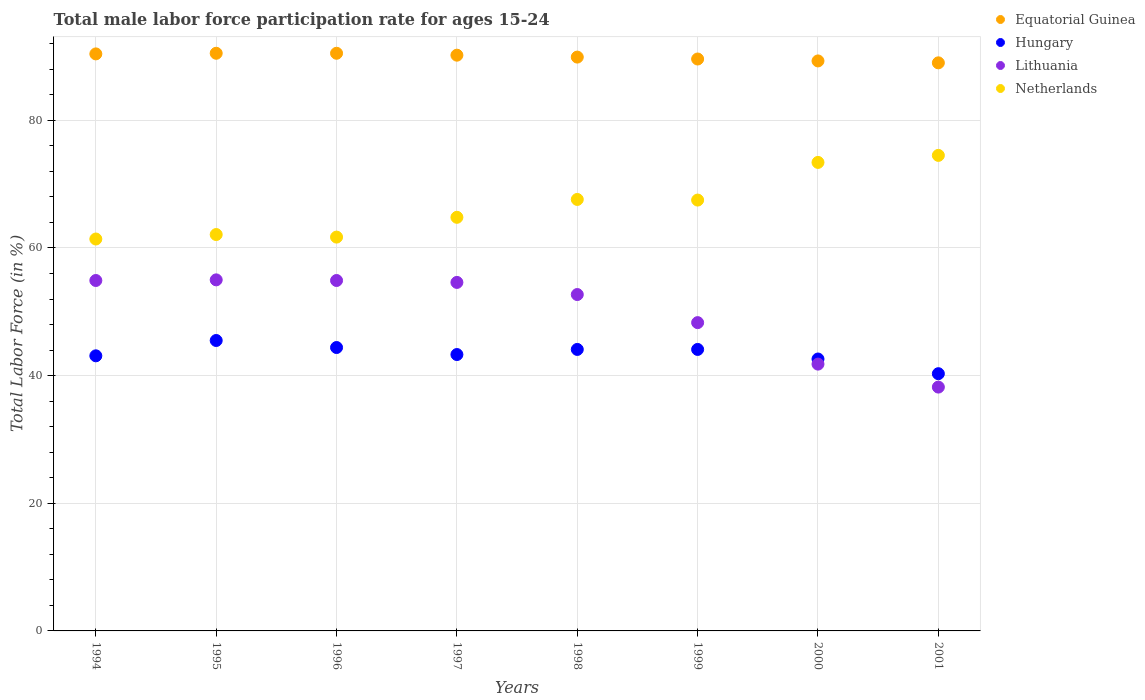How many different coloured dotlines are there?
Make the answer very short. 4. What is the male labor force participation rate in Netherlands in 1995?
Your answer should be compact. 62.1. Across all years, what is the maximum male labor force participation rate in Netherlands?
Offer a terse response. 74.5. Across all years, what is the minimum male labor force participation rate in Netherlands?
Keep it short and to the point. 61.4. In which year was the male labor force participation rate in Hungary minimum?
Keep it short and to the point. 2001. What is the total male labor force participation rate in Hungary in the graph?
Ensure brevity in your answer.  347.4. What is the difference between the male labor force participation rate in Netherlands in 1998 and that in 1999?
Give a very brief answer. 0.1. What is the difference between the male labor force participation rate in Lithuania in 1998 and the male labor force participation rate in Netherlands in 1997?
Ensure brevity in your answer.  -12.1. What is the average male labor force participation rate in Equatorial Guinea per year?
Keep it short and to the point. 89.93. In the year 2000, what is the difference between the male labor force participation rate in Lithuania and male labor force participation rate in Equatorial Guinea?
Make the answer very short. -47.5. What is the ratio of the male labor force participation rate in Lithuania in 1995 to that in 2001?
Offer a terse response. 1.44. What is the difference between the highest and the second highest male labor force participation rate in Lithuania?
Keep it short and to the point. 0.1. What is the difference between the highest and the lowest male labor force participation rate in Hungary?
Provide a succinct answer. 5.2. In how many years, is the male labor force participation rate in Hungary greater than the average male labor force participation rate in Hungary taken over all years?
Ensure brevity in your answer.  4. Is it the case that in every year, the sum of the male labor force participation rate in Equatorial Guinea and male labor force participation rate in Hungary  is greater than the sum of male labor force participation rate in Lithuania and male labor force participation rate in Netherlands?
Make the answer very short. No. How many dotlines are there?
Make the answer very short. 4. What is the difference between two consecutive major ticks on the Y-axis?
Provide a short and direct response. 20. Are the values on the major ticks of Y-axis written in scientific E-notation?
Your response must be concise. No. Does the graph contain any zero values?
Give a very brief answer. No. Does the graph contain grids?
Your response must be concise. Yes. Where does the legend appear in the graph?
Provide a short and direct response. Top right. How many legend labels are there?
Make the answer very short. 4. How are the legend labels stacked?
Offer a very short reply. Vertical. What is the title of the graph?
Give a very brief answer. Total male labor force participation rate for ages 15-24. What is the Total Labor Force (in %) of Equatorial Guinea in 1994?
Your answer should be very brief. 90.4. What is the Total Labor Force (in %) of Hungary in 1994?
Provide a succinct answer. 43.1. What is the Total Labor Force (in %) of Lithuania in 1994?
Offer a very short reply. 54.9. What is the Total Labor Force (in %) in Netherlands in 1994?
Ensure brevity in your answer.  61.4. What is the Total Labor Force (in %) in Equatorial Guinea in 1995?
Keep it short and to the point. 90.5. What is the Total Labor Force (in %) in Hungary in 1995?
Provide a short and direct response. 45.5. What is the Total Labor Force (in %) in Netherlands in 1995?
Provide a succinct answer. 62.1. What is the Total Labor Force (in %) of Equatorial Guinea in 1996?
Ensure brevity in your answer.  90.5. What is the Total Labor Force (in %) of Hungary in 1996?
Offer a very short reply. 44.4. What is the Total Labor Force (in %) in Lithuania in 1996?
Ensure brevity in your answer.  54.9. What is the Total Labor Force (in %) in Netherlands in 1996?
Give a very brief answer. 61.7. What is the Total Labor Force (in %) of Equatorial Guinea in 1997?
Provide a succinct answer. 90.2. What is the Total Labor Force (in %) of Hungary in 1997?
Offer a terse response. 43.3. What is the Total Labor Force (in %) in Lithuania in 1997?
Provide a succinct answer. 54.6. What is the Total Labor Force (in %) in Netherlands in 1997?
Keep it short and to the point. 64.8. What is the Total Labor Force (in %) in Equatorial Guinea in 1998?
Your answer should be very brief. 89.9. What is the Total Labor Force (in %) of Hungary in 1998?
Your response must be concise. 44.1. What is the Total Labor Force (in %) of Lithuania in 1998?
Your response must be concise. 52.7. What is the Total Labor Force (in %) in Netherlands in 1998?
Keep it short and to the point. 67.6. What is the Total Labor Force (in %) of Equatorial Guinea in 1999?
Ensure brevity in your answer.  89.6. What is the Total Labor Force (in %) of Hungary in 1999?
Keep it short and to the point. 44.1. What is the Total Labor Force (in %) of Lithuania in 1999?
Your response must be concise. 48.3. What is the Total Labor Force (in %) of Netherlands in 1999?
Offer a terse response. 67.5. What is the Total Labor Force (in %) of Equatorial Guinea in 2000?
Your answer should be very brief. 89.3. What is the Total Labor Force (in %) of Hungary in 2000?
Offer a terse response. 42.6. What is the Total Labor Force (in %) of Lithuania in 2000?
Your answer should be very brief. 41.8. What is the Total Labor Force (in %) of Netherlands in 2000?
Keep it short and to the point. 73.4. What is the Total Labor Force (in %) of Equatorial Guinea in 2001?
Your response must be concise. 89. What is the Total Labor Force (in %) in Hungary in 2001?
Offer a very short reply. 40.3. What is the Total Labor Force (in %) in Lithuania in 2001?
Provide a short and direct response. 38.2. What is the Total Labor Force (in %) in Netherlands in 2001?
Ensure brevity in your answer.  74.5. Across all years, what is the maximum Total Labor Force (in %) in Equatorial Guinea?
Your answer should be compact. 90.5. Across all years, what is the maximum Total Labor Force (in %) in Hungary?
Offer a very short reply. 45.5. Across all years, what is the maximum Total Labor Force (in %) in Netherlands?
Give a very brief answer. 74.5. Across all years, what is the minimum Total Labor Force (in %) of Equatorial Guinea?
Keep it short and to the point. 89. Across all years, what is the minimum Total Labor Force (in %) in Hungary?
Provide a succinct answer. 40.3. Across all years, what is the minimum Total Labor Force (in %) in Lithuania?
Provide a short and direct response. 38.2. Across all years, what is the minimum Total Labor Force (in %) in Netherlands?
Offer a terse response. 61.4. What is the total Total Labor Force (in %) of Equatorial Guinea in the graph?
Your response must be concise. 719.4. What is the total Total Labor Force (in %) of Hungary in the graph?
Your answer should be very brief. 347.4. What is the total Total Labor Force (in %) in Lithuania in the graph?
Your answer should be compact. 400.4. What is the total Total Labor Force (in %) in Netherlands in the graph?
Offer a very short reply. 533. What is the difference between the Total Labor Force (in %) of Lithuania in 1994 and that in 1995?
Offer a very short reply. -0.1. What is the difference between the Total Labor Force (in %) in Netherlands in 1994 and that in 1995?
Give a very brief answer. -0.7. What is the difference between the Total Labor Force (in %) in Netherlands in 1994 and that in 1996?
Offer a terse response. -0.3. What is the difference between the Total Labor Force (in %) of Equatorial Guinea in 1994 and that in 1997?
Give a very brief answer. 0.2. What is the difference between the Total Labor Force (in %) in Equatorial Guinea in 1994 and that in 1998?
Offer a very short reply. 0.5. What is the difference between the Total Labor Force (in %) in Lithuania in 1994 and that in 1998?
Make the answer very short. 2.2. What is the difference between the Total Labor Force (in %) in Equatorial Guinea in 1994 and that in 1999?
Offer a very short reply. 0.8. What is the difference between the Total Labor Force (in %) in Netherlands in 1994 and that in 1999?
Provide a short and direct response. -6.1. What is the difference between the Total Labor Force (in %) in Equatorial Guinea in 1994 and that in 2000?
Offer a terse response. 1.1. What is the difference between the Total Labor Force (in %) of Equatorial Guinea in 1994 and that in 2001?
Give a very brief answer. 1.4. What is the difference between the Total Labor Force (in %) in Netherlands in 1994 and that in 2001?
Give a very brief answer. -13.1. What is the difference between the Total Labor Force (in %) of Equatorial Guinea in 1995 and that in 1996?
Provide a succinct answer. 0. What is the difference between the Total Labor Force (in %) of Hungary in 1995 and that in 1996?
Your answer should be compact. 1.1. What is the difference between the Total Labor Force (in %) of Lithuania in 1995 and that in 1997?
Ensure brevity in your answer.  0.4. What is the difference between the Total Labor Force (in %) in Netherlands in 1995 and that in 1997?
Provide a short and direct response. -2.7. What is the difference between the Total Labor Force (in %) in Equatorial Guinea in 1995 and that in 1998?
Offer a terse response. 0.6. What is the difference between the Total Labor Force (in %) of Hungary in 1995 and that in 1998?
Provide a succinct answer. 1.4. What is the difference between the Total Labor Force (in %) of Netherlands in 1995 and that in 1998?
Ensure brevity in your answer.  -5.5. What is the difference between the Total Labor Force (in %) of Equatorial Guinea in 1995 and that in 1999?
Ensure brevity in your answer.  0.9. What is the difference between the Total Labor Force (in %) of Hungary in 1995 and that in 1999?
Offer a very short reply. 1.4. What is the difference between the Total Labor Force (in %) of Netherlands in 1995 and that in 1999?
Ensure brevity in your answer.  -5.4. What is the difference between the Total Labor Force (in %) in Equatorial Guinea in 1995 and that in 2000?
Ensure brevity in your answer.  1.2. What is the difference between the Total Labor Force (in %) in Hungary in 1995 and that in 2000?
Offer a terse response. 2.9. What is the difference between the Total Labor Force (in %) of Hungary in 1995 and that in 2001?
Offer a terse response. 5.2. What is the difference between the Total Labor Force (in %) of Netherlands in 1995 and that in 2001?
Your answer should be very brief. -12.4. What is the difference between the Total Labor Force (in %) in Hungary in 1996 and that in 1997?
Keep it short and to the point. 1.1. What is the difference between the Total Labor Force (in %) in Lithuania in 1996 and that in 1997?
Your answer should be compact. 0.3. What is the difference between the Total Labor Force (in %) in Equatorial Guinea in 1996 and that in 1998?
Provide a succinct answer. 0.6. What is the difference between the Total Labor Force (in %) in Lithuania in 1996 and that in 1998?
Your response must be concise. 2.2. What is the difference between the Total Labor Force (in %) of Equatorial Guinea in 1996 and that in 1999?
Your answer should be compact. 0.9. What is the difference between the Total Labor Force (in %) in Hungary in 1996 and that in 1999?
Provide a short and direct response. 0.3. What is the difference between the Total Labor Force (in %) in Equatorial Guinea in 1996 and that in 2000?
Give a very brief answer. 1.2. What is the difference between the Total Labor Force (in %) of Hungary in 1996 and that in 2000?
Your answer should be very brief. 1.8. What is the difference between the Total Labor Force (in %) of Lithuania in 1996 and that in 2000?
Your answer should be compact. 13.1. What is the difference between the Total Labor Force (in %) of Netherlands in 1996 and that in 2000?
Provide a succinct answer. -11.7. What is the difference between the Total Labor Force (in %) in Equatorial Guinea in 1996 and that in 2001?
Make the answer very short. 1.5. What is the difference between the Total Labor Force (in %) in Equatorial Guinea in 1997 and that in 1998?
Your answer should be compact. 0.3. What is the difference between the Total Labor Force (in %) of Equatorial Guinea in 1997 and that in 1999?
Your answer should be compact. 0.6. What is the difference between the Total Labor Force (in %) in Netherlands in 1997 and that in 1999?
Keep it short and to the point. -2.7. What is the difference between the Total Labor Force (in %) of Equatorial Guinea in 1997 and that in 2001?
Keep it short and to the point. 1.2. What is the difference between the Total Labor Force (in %) in Netherlands in 1997 and that in 2001?
Provide a succinct answer. -9.7. What is the difference between the Total Labor Force (in %) of Netherlands in 1998 and that in 2000?
Keep it short and to the point. -5.8. What is the difference between the Total Labor Force (in %) in Hungary in 1998 and that in 2001?
Give a very brief answer. 3.8. What is the difference between the Total Labor Force (in %) in Lithuania in 1998 and that in 2001?
Keep it short and to the point. 14.5. What is the difference between the Total Labor Force (in %) in Netherlands in 1998 and that in 2001?
Keep it short and to the point. -6.9. What is the difference between the Total Labor Force (in %) of Hungary in 1999 and that in 2000?
Give a very brief answer. 1.5. What is the difference between the Total Labor Force (in %) in Lithuania in 1999 and that in 2000?
Offer a terse response. 6.5. What is the difference between the Total Labor Force (in %) in Netherlands in 1999 and that in 2000?
Make the answer very short. -5.9. What is the difference between the Total Labor Force (in %) in Netherlands in 1999 and that in 2001?
Make the answer very short. -7. What is the difference between the Total Labor Force (in %) in Hungary in 2000 and that in 2001?
Make the answer very short. 2.3. What is the difference between the Total Labor Force (in %) in Lithuania in 2000 and that in 2001?
Ensure brevity in your answer.  3.6. What is the difference between the Total Labor Force (in %) in Equatorial Guinea in 1994 and the Total Labor Force (in %) in Hungary in 1995?
Your answer should be very brief. 44.9. What is the difference between the Total Labor Force (in %) of Equatorial Guinea in 1994 and the Total Labor Force (in %) of Lithuania in 1995?
Make the answer very short. 35.4. What is the difference between the Total Labor Force (in %) of Equatorial Guinea in 1994 and the Total Labor Force (in %) of Netherlands in 1995?
Your answer should be very brief. 28.3. What is the difference between the Total Labor Force (in %) of Equatorial Guinea in 1994 and the Total Labor Force (in %) of Lithuania in 1996?
Offer a terse response. 35.5. What is the difference between the Total Labor Force (in %) of Equatorial Guinea in 1994 and the Total Labor Force (in %) of Netherlands in 1996?
Provide a succinct answer. 28.7. What is the difference between the Total Labor Force (in %) in Hungary in 1994 and the Total Labor Force (in %) in Lithuania in 1996?
Give a very brief answer. -11.8. What is the difference between the Total Labor Force (in %) of Hungary in 1994 and the Total Labor Force (in %) of Netherlands in 1996?
Your answer should be compact. -18.6. What is the difference between the Total Labor Force (in %) of Lithuania in 1994 and the Total Labor Force (in %) of Netherlands in 1996?
Ensure brevity in your answer.  -6.8. What is the difference between the Total Labor Force (in %) of Equatorial Guinea in 1994 and the Total Labor Force (in %) of Hungary in 1997?
Your answer should be compact. 47.1. What is the difference between the Total Labor Force (in %) of Equatorial Guinea in 1994 and the Total Labor Force (in %) of Lithuania in 1997?
Provide a succinct answer. 35.8. What is the difference between the Total Labor Force (in %) of Equatorial Guinea in 1994 and the Total Labor Force (in %) of Netherlands in 1997?
Offer a very short reply. 25.6. What is the difference between the Total Labor Force (in %) in Hungary in 1994 and the Total Labor Force (in %) in Netherlands in 1997?
Keep it short and to the point. -21.7. What is the difference between the Total Labor Force (in %) in Equatorial Guinea in 1994 and the Total Labor Force (in %) in Hungary in 1998?
Ensure brevity in your answer.  46.3. What is the difference between the Total Labor Force (in %) in Equatorial Guinea in 1994 and the Total Labor Force (in %) in Lithuania in 1998?
Offer a very short reply. 37.7. What is the difference between the Total Labor Force (in %) in Equatorial Guinea in 1994 and the Total Labor Force (in %) in Netherlands in 1998?
Your answer should be compact. 22.8. What is the difference between the Total Labor Force (in %) in Hungary in 1994 and the Total Labor Force (in %) in Netherlands in 1998?
Your response must be concise. -24.5. What is the difference between the Total Labor Force (in %) in Equatorial Guinea in 1994 and the Total Labor Force (in %) in Hungary in 1999?
Your answer should be compact. 46.3. What is the difference between the Total Labor Force (in %) in Equatorial Guinea in 1994 and the Total Labor Force (in %) in Lithuania in 1999?
Provide a succinct answer. 42.1. What is the difference between the Total Labor Force (in %) in Equatorial Guinea in 1994 and the Total Labor Force (in %) in Netherlands in 1999?
Your answer should be compact. 22.9. What is the difference between the Total Labor Force (in %) of Hungary in 1994 and the Total Labor Force (in %) of Lithuania in 1999?
Make the answer very short. -5.2. What is the difference between the Total Labor Force (in %) in Hungary in 1994 and the Total Labor Force (in %) in Netherlands in 1999?
Your answer should be very brief. -24.4. What is the difference between the Total Labor Force (in %) in Lithuania in 1994 and the Total Labor Force (in %) in Netherlands in 1999?
Your answer should be compact. -12.6. What is the difference between the Total Labor Force (in %) of Equatorial Guinea in 1994 and the Total Labor Force (in %) of Hungary in 2000?
Your response must be concise. 47.8. What is the difference between the Total Labor Force (in %) of Equatorial Guinea in 1994 and the Total Labor Force (in %) of Lithuania in 2000?
Your answer should be very brief. 48.6. What is the difference between the Total Labor Force (in %) of Equatorial Guinea in 1994 and the Total Labor Force (in %) of Netherlands in 2000?
Make the answer very short. 17. What is the difference between the Total Labor Force (in %) of Hungary in 1994 and the Total Labor Force (in %) of Lithuania in 2000?
Offer a terse response. 1.3. What is the difference between the Total Labor Force (in %) in Hungary in 1994 and the Total Labor Force (in %) in Netherlands in 2000?
Provide a succinct answer. -30.3. What is the difference between the Total Labor Force (in %) in Lithuania in 1994 and the Total Labor Force (in %) in Netherlands in 2000?
Your answer should be compact. -18.5. What is the difference between the Total Labor Force (in %) in Equatorial Guinea in 1994 and the Total Labor Force (in %) in Hungary in 2001?
Your answer should be very brief. 50.1. What is the difference between the Total Labor Force (in %) of Equatorial Guinea in 1994 and the Total Labor Force (in %) of Lithuania in 2001?
Your answer should be very brief. 52.2. What is the difference between the Total Labor Force (in %) of Equatorial Guinea in 1994 and the Total Labor Force (in %) of Netherlands in 2001?
Your answer should be very brief. 15.9. What is the difference between the Total Labor Force (in %) of Hungary in 1994 and the Total Labor Force (in %) of Lithuania in 2001?
Offer a terse response. 4.9. What is the difference between the Total Labor Force (in %) in Hungary in 1994 and the Total Labor Force (in %) in Netherlands in 2001?
Keep it short and to the point. -31.4. What is the difference between the Total Labor Force (in %) of Lithuania in 1994 and the Total Labor Force (in %) of Netherlands in 2001?
Your answer should be compact. -19.6. What is the difference between the Total Labor Force (in %) in Equatorial Guinea in 1995 and the Total Labor Force (in %) in Hungary in 1996?
Keep it short and to the point. 46.1. What is the difference between the Total Labor Force (in %) in Equatorial Guinea in 1995 and the Total Labor Force (in %) in Lithuania in 1996?
Your answer should be very brief. 35.6. What is the difference between the Total Labor Force (in %) in Equatorial Guinea in 1995 and the Total Labor Force (in %) in Netherlands in 1996?
Keep it short and to the point. 28.8. What is the difference between the Total Labor Force (in %) of Hungary in 1995 and the Total Labor Force (in %) of Lithuania in 1996?
Your answer should be compact. -9.4. What is the difference between the Total Labor Force (in %) in Hungary in 1995 and the Total Labor Force (in %) in Netherlands in 1996?
Make the answer very short. -16.2. What is the difference between the Total Labor Force (in %) in Lithuania in 1995 and the Total Labor Force (in %) in Netherlands in 1996?
Your response must be concise. -6.7. What is the difference between the Total Labor Force (in %) in Equatorial Guinea in 1995 and the Total Labor Force (in %) in Hungary in 1997?
Give a very brief answer. 47.2. What is the difference between the Total Labor Force (in %) of Equatorial Guinea in 1995 and the Total Labor Force (in %) of Lithuania in 1997?
Your response must be concise. 35.9. What is the difference between the Total Labor Force (in %) of Equatorial Guinea in 1995 and the Total Labor Force (in %) of Netherlands in 1997?
Give a very brief answer. 25.7. What is the difference between the Total Labor Force (in %) in Hungary in 1995 and the Total Labor Force (in %) in Netherlands in 1997?
Provide a succinct answer. -19.3. What is the difference between the Total Labor Force (in %) of Lithuania in 1995 and the Total Labor Force (in %) of Netherlands in 1997?
Give a very brief answer. -9.8. What is the difference between the Total Labor Force (in %) of Equatorial Guinea in 1995 and the Total Labor Force (in %) of Hungary in 1998?
Give a very brief answer. 46.4. What is the difference between the Total Labor Force (in %) in Equatorial Guinea in 1995 and the Total Labor Force (in %) in Lithuania in 1998?
Your answer should be very brief. 37.8. What is the difference between the Total Labor Force (in %) in Equatorial Guinea in 1995 and the Total Labor Force (in %) in Netherlands in 1998?
Make the answer very short. 22.9. What is the difference between the Total Labor Force (in %) of Hungary in 1995 and the Total Labor Force (in %) of Lithuania in 1998?
Keep it short and to the point. -7.2. What is the difference between the Total Labor Force (in %) of Hungary in 1995 and the Total Labor Force (in %) of Netherlands in 1998?
Make the answer very short. -22.1. What is the difference between the Total Labor Force (in %) in Equatorial Guinea in 1995 and the Total Labor Force (in %) in Hungary in 1999?
Your answer should be compact. 46.4. What is the difference between the Total Labor Force (in %) of Equatorial Guinea in 1995 and the Total Labor Force (in %) of Lithuania in 1999?
Offer a terse response. 42.2. What is the difference between the Total Labor Force (in %) of Equatorial Guinea in 1995 and the Total Labor Force (in %) of Hungary in 2000?
Your answer should be very brief. 47.9. What is the difference between the Total Labor Force (in %) of Equatorial Guinea in 1995 and the Total Labor Force (in %) of Lithuania in 2000?
Give a very brief answer. 48.7. What is the difference between the Total Labor Force (in %) in Hungary in 1995 and the Total Labor Force (in %) in Netherlands in 2000?
Your answer should be compact. -27.9. What is the difference between the Total Labor Force (in %) in Lithuania in 1995 and the Total Labor Force (in %) in Netherlands in 2000?
Your answer should be compact. -18.4. What is the difference between the Total Labor Force (in %) of Equatorial Guinea in 1995 and the Total Labor Force (in %) of Hungary in 2001?
Your answer should be compact. 50.2. What is the difference between the Total Labor Force (in %) of Equatorial Guinea in 1995 and the Total Labor Force (in %) of Lithuania in 2001?
Offer a terse response. 52.3. What is the difference between the Total Labor Force (in %) of Equatorial Guinea in 1995 and the Total Labor Force (in %) of Netherlands in 2001?
Your response must be concise. 16. What is the difference between the Total Labor Force (in %) in Hungary in 1995 and the Total Labor Force (in %) in Netherlands in 2001?
Provide a succinct answer. -29. What is the difference between the Total Labor Force (in %) of Lithuania in 1995 and the Total Labor Force (in %) of Netherlands in 2001?
Offer a terse response. -19.5. What is the difference between the Total Labor Force (in %) in Equatorial Guinea in 1996 and the Total Labor Force (in %) in Hungary in 1997?
Your answer should be compact. 47.2. What is the difference between the Total Labor Force (in %) of Equatorial Guinea in 1996 and the Total Labor Force (in %) of Lithuania in 1997?
Keep it short and to the point. 35.9. What is the difference between the Total Labor Force (in %) in Equatorial Guinea in 1996 and the Total Labor Force (in %) in Netherlands in 1997?
Provide a succinct answer. 25.7. What is the difference between the Total Labor Force (in %) of Hungary in 1996 and the Total Labor Force (in %) of Lithuania in 1997?
Offer a terse response. -10.2. What is the difference between the Total Labor Force (in %) of Hungary in 1996 and the Total Labor Force (in %) of Netherlands in 1997?
Offer a very short reply. -20.4. What is the difference between the Total Labor Force (in %) of Lithuania in 1996 and the Total Labor Force (in %) of Netherlands in 1997?
Give a very brief answer. -9.9. What is the difference between the Total Labor Force (in %) of Equatorial Guinea in 1996 and the Total Labor Force (in %) of Hungary in 1998?
Keep it short and to the point. 46.4. What is the difference between the Total Labor Force (in %) in Equatorial Guinea in 1996 and the Total Labor Force (in %) in Lithuania in 1998?
Make the answer very short. 37.8. What is the difference between the Total Labor Force (in %) of Equatorial Guinea in 1996 and the Total Labor Force (in %) of Netherlands in 1998?
Give a very brief answer. 22.9. What is the difference between the Total Labor Force (in %) in Hungary in 1996 and the Total Labor Force (in %) in Netherlands in 1998?
Offer a very short reply. -23.2. What is the difference between the Total Labor Force (in %) of Equatorial Guinea in 1996 and the Total Labor Force (in %) of Hungary in 1999?
Your answer should be compact. 46.4. What is the difference between the Total Labor Force (in %) of Equatorial Guinea in 1996 and the Total Labor Force (in %) of Lithuania in 1999?
Provide a short and direct response. 42.2. What is the difference between the Total Labor Force (in %) of Hungary in 1996 and the Total Labor Force (in %) of Lithuania in 1999?
Provide a succinct answer. -3.9. What is the difference between the Total Labor Force (in %) of Hungary in 1996 and the Total Labor Force (in %) of Netherlands in 1999?
Offer a terse response. -23.1. What is the difference between the Total Labor Force (in %) in Equatorial Guinea in 1996 and the Total Labor Force (in %) in Hungary in 2000?
Give a very brief answer. 47.9. What is the difference between the Total Labor Force (in %) of Equatorial Guinea in 1996 and the Total Labor Force (in %) of Lithuania in 2000?
Make the answer very short. 48.7. What is the difference between the Total Labor Force (in %) in Hungary in 1996 and the Total Labor Force (in %) in Lithuania in 2000?
Make the answer very short. 2.6. What is the difference between the Total Labor Force (in %) of Hungary in 1996 and the Total Labor Force (in %) of Netherlands in 2000?
Your answer should be compact. -29. What is the difference between the Total Labor Force (in %) in Lithuania in 1996 and the Total Labor Force (in %) in Netherlands in 2000?
Keep it short and to the point. -18.5. What is the difference between the Total Labor Force (in %) in Equatorial Guinea in 1996 and the Total Labor Force (in %) in Hungary in 2001?
Offer a very short reply. 50.2. What is the difference between the Total Labor Force (in %) of Equatorial Guinea in 1996 and the Total Labor Force (in %) of Lithuania in 2001?
Ensure brevity in your answer.  52.3. What is the difference between the Total Labor Force (in %) in Hungary in 1996 and the Total Labor Force (in %) in Lithuania in 2001?
Provide a short and direct response. 6.2. What is the difference between the Total Labor Force (in %) of Hungary in 1996 and the Total Labor Force (in %) of Netherlands in 2001?
Make the answer very short. -30.1. What is the difference between the Total Labor Force (in %) in Lithuania in 1996 and the Total Labor Force (in %) in Netherlands in 2001?
Give a very brief answer. -19.6. What is the difference between the Total Labor Force (in %) in Equatorial Guinea in 1997 and the Total Labor Force (in %) in Hungary in 1998?
Offer a terse response. 46.1. What is the difference between the Total Labor Force (in %) in Equatorial Guinea in 1997 and the Total Labor Force (in %) in Lithuania in 1998?
Offer a very short reply. 37.5. What is the difference between the Total Labor Force (in %) of Equatorial Guinea in 1997 and the Total Labor Force (in %) of Netherlands in 1998?
Your answer should be very brief. 22.6. What is the difference between the Total Labor Force (in %) of Hungary in 1997 and the Total Labor Force (in %) of Lithuania in 1998?
Make the answer very short. -9.4. What is the difference between the Total Labor Force (in %) in Hungary in 1997 and the Total Labor Force (in %) in Netherlands in 1998?
Your answer should be compact. -24.3. What is the difference between the Total Labor Force (in %) of Lithuania in 1997 and the Total Labor Force (in %) of Netherlands in 1998?
Give a very brief answer. -13. What is the difference between the Total Labor Force (in %) in Equatorial Guinea in 1997 and the Total Labor Force (in %) in Hungary in 1999?
Your answer should be compact. 46.1. What is the difference between the Total Labor Force (in %) in Equatorial Guinea in 1997 and the Total Labor Force (in %) in Lithuania in 1999?
Ensure brevity in your answer.  41.9. What is the difference between the Total Labor Force (in %) of Equatorial Guinea in 1997 and the Total Labor Force (in %) of Netherlands in 1999?
Provide a short and direct response. 22.7. What is the difference between the Total Labor Force (in %) in Hungary in 1997 and the Total Labor Force (in %) in Lithuania in 1999?
Provide a succinct answer. -5. What is the difference between the Total Labor Force (in %) of Hungary in 1997 and the Total Labor Force (in %) of Netherlands in 1999?
Your response must be concise. -24.2. What is the difference between the Total Labor Force (in %) in Lithuania in 1997 and the Total Labor Force (in %) in Netherlands in 1999?
Make the answer very short. -12.9. What is the difference between the Total Labor Force (in %) of Equatorial Guinea in 1997 and the Total Labor Force (in %) of Hungary in 2000?
Offer a very short reply. 47.6. What is the difference between the Total Labor Force (in %) of Equatorial Guinea in 1997 and the Total Labor Force (in %) of Lithuania in 2000?
Your answer should be very brief. 48.4. What is the difference between the Total Labor Force (in %) in Hungary in 1997 and the Total Labor Force (in %) in Lithuania in 2000?
Make the answer very short. 1.5. What is the difference between the Total Labor Force (in %) in Hungary in 1997 and the Total Labor Force (in %) in Netherlands in 2000?
Make the answer very short. -30.1. What is the difference between the Total Labor Force (in %) in Lithuania in 1997 and the Total Labor Force (in %) in Netherlands in 2000?
Ensure brevity in your answer.  -18.8. What is the difference between the Total Labor Force (in %) in Equatorial Guinea in 1997 and the Total Labor Force (in %) in Hungary in 2001?
Provide a succinct answer. 49.9. What is the difference between the Total Labor Force (in %) of Hungary in 1997 and the Total Labor Force (in %) of Lithuania in 2001?
Keep it short and to the point. 5.1. What is the difference between the Total Labor Force (in %) of Hungary in 1997 and the Total Labor Force (in %) of Netherlands in 2001?
Provide a succinct answer. -31.2. What is the difference between the Total Labor Force (in %) in Lithuania in 1997 and the Total Labor Force (in %) in Netherlands in 2001?
Make the answer very short. -19.9. What is the difference between the Total Labor Force (in %) of Equatorial Guinea in 1998 and the Total Labor Force (in %) of Hungary in 1999?
Keep it short and to the point. 45.8. What is the difference between the Total Labor Force (in %) of Equatorial Guinea in 1998 and the Total Labor Force (in %) of Lithuania in 1999?
Give a very brief answer. 41.6. What is the difference between the Total Labor Force (in %) in Equatorial Guinea in 1998 and the Total Labor Force (in %) in Netherlands in 1999?
Provide a short and direct response. 22.4. What is the difference between the Total Labor Force (in %) of Hungary in 1998 and the Total Labor Force (in %) of Lithuania in 1999?
Offer a terse response. -4.2. What is the difference between the Total Labor Force (in %) in Hungary in 1998 and the Total Labor Force (in %) in Netherlands in 1999?
Your response must be concise. -23.4. What is the difference between the Total Labor Force (in %) of Lithuania in 1998 and the Total Labor Force (in %) of Netherlands in 1999?
Offer a terse response. -14.8. What is the difference between the Total Labor Force (in %) of Equatorial Guinea in 1998 and the Total Labor Force (in %) of Hungary in 2000?
Ensure brevity in your answer.  47.3. What is the difference between the Total Labor Force (in %) in Equatorial Guinea in 1998 and the Total Labor Force (in %) in Lithuania in 2000?
Give a very brief answer. 48.1. What is the difference between the Total Labor Force (in %) in Hungary in 1998 and the Total Labor Force (in %) in Lithuania in 2000?
Your response must be concise. 2.3. What is the difference between the Total Labor Force (in %) of Hungary in 1998 and the Total Labor Force (in %) of Netherlands in 2000?
Offer a terse response. -29.3. What is the difference between the Total Labor Force (in %) of Lithuania in 1998 and the Total Labor Force (in %) of Netherlands in 2000?
Your response must be concise. -20.7. What is the difference between the Total Labor Force (in %) of Equatorial Guinea in 1998 and the Total Labor Force (in %) of Hungary in 2001?
Keep it short and to the point. 49.6. What is the difference between the Total Labor Force (in %) of Equatorial Guinea in 1998 and the Total Labor Force (in %) of Lithuania in 2001?
Provide a succinct answer. 51.7. What is the difference between the Total Labor Force (in %) in Equatorial Guinea in 1998 and the Total Labor Force (in %) in Netherlands in 2001?
Provide a succinct answer. 15.4. What is the difference between the Total Labor Force (in %) in Hungary in 1998 and the Total Labor Force (in %) in Lithuania in 2001?
Offer a very short reply. 5.9. What is the difference between the Total Labor Force (in %) in Hungary in 1998 and the Total Labor Force (in %) in Netherlands in 2001?
Your response must be concise. -30.4. What is the difference between the Total Labor Force (in %) in Lithuania in 1998 and the Total Labor Force (in %) in Netherlands in 2001?
Keep it short and to the point. -21.8. What is the difference between the Total Labor Force (in %) in Equatorial Guinea in 1999 and the Total Labor Force (in %) in Hungary in 2000?
Offer a very short reply. 47. What is the difference between the Total Labor Force (in %) in Equatorial Guinea in 1999 and the Total Labor Force (in %) in Lithuania in 2000?
Offer a very short reply. 47.8. What is the difference between the Total Labor Force (in %) in Equatorial Guinea in 1999 and the Total Labor Force (in %) in Netherlands in 2000?
Make the answer very short. 16.2. What is the difference between the Total Labor Force (in %) in Hungary in 1999 and the Total Labor Force (in %) in Lithuania in 2000?
Your answer should be very brief. 2.3. What is the difference between the Total Labor Force (in %) of Hungary in 1999 and the Total Labor Force (in %) of Netherlands in 2000?
Ensure brevity in your answer.  -29.3. What is the difference between the Total Labor Force (in %) of Lithuania in 1999 and the Total Labor Force (in %) of Netherlands in 2000?
Provide a succinct answer. -25.1. What is the difference between the Total Labor Force (in %) in Equatorial Guinea in 1999 and the Total Labor Force (in %) in Hungary in 2001?
Ensure brevity in your answer.  49.3. What is the difference between the Total Labor Force (in %) of Equatorial Guinea in 1999 and the Total Labor Force (in %) of Lithuania in 2001?
Your answer should be very brief. 51.4. What is the difference between the Total Labor Force (in %) in Hungary in 1999 and the Total Labor Force (in %) in Lithuania in 2001?
Provide a succinct answer. 5.9. What is the difference between the Total Labor Force (in %) of Hungary in 1999 and the Total Labor Force (in %) of Netherlands in 2001?
Keep it short and to the point. -30.4. What is the difference between the Total Labor Force (in %) in Lithuania in 1999 and the Total Labor Force (in %) in Netherlands in 2001?
Keep it short and to the point. -26.2. What is the difference between the Total Labor Force (in %) of Equatorial Guinea in 2000 and the Total Labor Force (in %) of Lithuania in 2001?
Offer a very short reply. 51.1. What is the difference between the Total Labor Force (in %) in Hungary in 2000 and the Total Labor Force (in %) in Lithuania in 2001?
Your answer should be very brief. 4.4. What is the difference between the Total Labor Force (in %) of Hungary in 2000 and the Total Labor Force (in %) of Netherlands in 2001?
Provide a short and direct response. -31.9. What is the difference between the Total Labor Force (in %) in Lithuania in 2000 and the Total Labor Force (in %) in Netherlands in 2001?
Make the answer very short. -32.7. What is the average Total Labor Force (in %) of Equatorial Guinea per year?
Offer a very short reply. 89.92. What is the average Total Labor Force (in %) in Hungary per year?
Provide a short and direct response. 43.42. What is the average Total Labor Force (in %) of Lithuania per year?
Keep it short and to the point. 50.05. What is the average Total Labor Force (in %) in Netherlands per year?
Provide a short and direct response. 66.62. In the year 1994, what is the difference between the Total Labor Force (in %) in Equatorial Guinea and Total Labor Force (in %) in Hungary?
Provide a short and direct response. 47.3. In the year 1994, what is the difference between the Total Labor Force (in %) in Equatorial Guinea and Total Labor Force (in %) in Lithuania?
Ensure brevity in your answer.  35.5. In the year 1994, what is the difference between the Total Labor Force (in %) of Equatorial Guinea and Total Labor Force (in %) of Netherlands?
Offer a terse response. 29. In the year 1994, what is the difference between the Total Labor Force (in %) of Hungary and Total Labor Force (in %) of Lithuania?
Offer a very short reply. -11.8. In the year 1994, what is the difference between the Total Labor Force (in %) in Hungary and Total Labor Force (in %) in Netherlands?
Offer a very short reply. -18.3. In the year 1994, what is the difference between the Total Labor Force (in %) in Lithuania and Total Labor Force (in %) in Netherlands?
Make the answer very short. -6.5. In the year 1995, what is the difference between the Total Labor Force (in %) of Equatorial Guinea and Total Labor Force (in %) of Hungary?
Offer a very short reply. 45. In the year 1995, what is the difference between the Total Labor Force (in %) of Equatorial Guinea and Total Labor Force (in %) of Lithuania?
Provide a succinct answer. 35.5. In the year 1995, what is the difference between the Total Labor Force (in %) of Equatorial Guinea and Total Labor Force (in %) of Netherlands?
Offer a terse response. 28.4. In the year 1995, what is the difference between the Total Labor Force (in %) of Hungary and Total Labor Force (in %) of Lithuania?
Your response must be concise. -9.5. In the year 1995, what is the difference between the Total Labor Force (in %) in Hungary and Total Labor Force (in %) in Netherlands?
Your response must be concise. -16.6. In the year 1996, what is the difference between the Total Labor Force (in %) of Equatorial Guinea and Total Labor Force (in %) of Hungary?
Your answer should be compact. 46.1. In the year 1996, what is the difference between the Total Labor Force (in %) in Equatorial Guinea and Total Labor Force (in %) in Lithuania?
Offer a very short reply. 35.6. In the year 1996, what is the difference between the Total Labor Force (in %) of Equatorial Guinea and Total Labor Force (in %) of Netherlands?
Offer a terse response. 28.8. In the year 1996, what is the difference between the Total Labor Force (in %) of Hungary and Total Labor Force (in %) of Netherlands?
Offer a very short reply. -17.3. In the year 1997, what is the difference between the Total Labor Force (in %) of Equatorial Guinea and Total Labor Force (in %) of Hungary?
Offer a terse response. 46.9. In the year 1997, what is the difference between the Total Labor Force (in %) of Equatorial Guinea and Total Labor Force (in %) of Lithuania?
Provide a short and direct response. 35.6. In the year 1997, what is the difference between the Total Labor Force (in %) of Equatorial Guinea and Total Labor Force (in %) of Netherlands?
Ensure brevity in your answer.  25.4. In the year 1997, what is the difference between the Total Labor Force (in %) of Hungary and Total Labor Force (in %) of Netherlands?
Provide a short and direct response. -21.5. In the year 1998, what is the difference between the Total Labor Force (in %) in Equatorial Guinea and Total Labor Force (in %) in Hungary?
Offer a very short reply. 45.8. In the year 1998, what is the difference between the Total Labor Force (in %) of Equatorial Guinea and Total Labor Force (in %) of Lithuania?
Provide a succinct answer. 37.2. In the year 1998, what is the difference between the Total Labor Force (in %) in Equatorial Guinea and Total Labor Force (in %) in Netherlands?
Offer a terse response. 22.3. In the year 1998, what is the difference between the Total Labor Force (in %) in Hungary and Total Labor Force (in %) in Netherlands?
Offer a very short reply. -23.5. In the year 1998, what is the difference between the Total Labor Force (in %) in Lithuania and Total Labor Force (in %) in Netherlands?
Your answer should be very brief. -14.9. In the year 1999, what is the difference between the Total Labor Force (in %) of Equatorial Guinea and Total Labor Force (in %) of Hungary?
Provide a succinct answer. 45.5. In the year 1999, what is the difference between the Total Labor Force (in %) in Equatorial Guinea and Total Labor Force (in %) in Lithuania?
Ensure brevity in your answer.  41.3. In the year 1999, what is the difference between the Total Labor Force (in %) of Equatorial Guinea and Total Labor Force (in %) of Netherlands?
Provide a succinct answer. 22.1. In the year 1999, what is the difference between the Total Labor Force (in %) of Hungary and Total Labor Force (in %) of Netherlands?
Provide a succinct answer. -23.4. In the year 1999, what is the difference between the Total Labor Force (in %) of Lithuania and Total Labor Force (in %) of Netherlands?
Your answer should be very brief. -19.2. In the year 2000, what is the difference between the Total Labor Force (in %) of Equatorial Guinea and Total Labor Force (in %) of Hungary?
Give a very brief answer. 46.7. In the year 2000, what is the difference between the Total Labor Force (in %) in Equatorial Guinea and Total Labor Force (in %) in Lithuania?
Offer a very short reply. 47.5. In the year 2000, what is the difference between the Total Labor Force (in %) in Equatorial Guinea and Total Labor Force (in %) in Netherlands?
Make the answer very short. 15.9. In the year 2000, what is the difference between the Total Labor Force (in %) of Hungary and Total Labor Force (in %) of Netherlands?
Your response must be concise. -30.8. In the year 2000, what is the difference between the Total Labor Force (in %) in Lithuania and Total Labor Force (in %) in Netherlands?
Your answer should be very brief. -31.6. In the year 2001, what is the difference between the Total Labor Force (in %) of Equatorial Guinea and Total Labor Force (in %) of Hungary?
Provide a succinct answer. 48.7. In the year 2001, what is the difference between the Total Labor Force (in %) in Equatorial Guinea and Total Labor Force (in %) in Lithuania?
Provide a short and direct response. 50.8. In the year 2001, what is the difference between the Total Labor Force (in %) of Equatorial Guinea and Total Labor Force (in %) of Netherlands?
Make the answer very short. 14.5. In the year 2001, what is the difference between the Total Labor Force (in %) of Hungary and Total Labor Force (in %) of Lithuania?
Give a very brief answer. 2.1. In the year 2001, what is the difference between the Total Labor Force (in %) of Hungary and Total Labor Force (in %) of Netherlands?
Provide a succinct answer. -34.2. In the year 2001, what is the difference between the Total Labor Force (in %) in Lithuania and Total Labor Force (in %) in Netherlands?
Offer a very short reply. -36.3. What is the ratio of the Total Labor Force (in %) in Hungary in 1994 to that in 1995?
Your answer should be compact. 0.95. What is the ratio of the Total Labor Force (in %) in Netherlands in 1994 to that in 1995?
Give a very brief answer. 0.99. What is the ratio of the Total Labor Force (in %) of Equatorial Guinea in 1994 to that in 1996?
Offer a terse response. 1. What is the ratio of the Total Labor Force (in %) in Hungary in 1994 to that in 1996?
Ensure brevity in your answer.  0.97. What is the ratio of the Total Labor Force (in %) in Lithuania in 1994 to that in 1996?
Ensure brevity in your answer.  1. What is the ratio of the Total Labor Force (in %) in Equatorial Guinea in 1994 to that in 1997?
Give a very brief answer. 1. What is the ratio of the Total Labor Force (in %) in Hungary in 1994 to that in 1997?
Keep it short and to the point. 1. What is the ratio of the Total Labor Force (in %) of Lithuania in 1994 to that in 1997?
Your answer should be compact. 1.01. What is the ratio of the Total Labor Force (in %) in Netherlands in 1994 to that in 1997?
Keep it short and to the point. 0.95. What is the ratio of the Total Labor Force (in %) of Equatorial Guinea in 1994 to that in 1998?
Make the answer very short. 1.01. What is the ratio of the Total Labor Force (in %) in Hungary in 1994 to that in 1998?
Provide a succinct answer. 0.98. What is the ratio of the Total Labor Force (in %) of Lithuania in 1994 to that in 1998?
Ensure brevity in your answer.  1.04. What is the ratio of the Total Labor Force (in %) of Netherlands in 1994 to that in 1998?
Offer a terse response. 0.91. What is the ratio of the Total Labor Force (in %) in Equatorial Guinea in 1994 to that in 1999?
Your response must be concise. 1.01. What is the ratio of the Total Labor Force (in %) in Hungary in 1994 to that in 1999?
Make the answer very short. 0.98. What is the ratio of the Total Labor Force (in %) in Lithuania in 1994 to that in 1999?
Give a very brief answer. 1.14. What is the ratio of the Total Labor Force (in %) of Netherlands in 1994 to that in 1999?
Ensure brevity in your answer.  0.91. What is the ratio of the Total Labor Force (in %) of Equatorial Guinea in 1994 to that in 2000?
Your response must be concise. 1.01. What is the ratio of the Total Labor Force (in %) of Hungary in 1994 to that in 2000?
Offer a very short reply. 1.01. What is the ratio of the Total Labor Force (in %) of Lithuania in 1994 to that in 2000?
Make the answer very short. 1.31. What is the ratio of the Total Labor Force (in %) of Netherlands in 1994 to that in 2000?
Your answer should be very brief. 0.84. What is the ratio of the Total Labor Force (in %) of Equatorial Guinea in 1994 to that in 2001?
Provide a succinct answer. 1.02. What is the ratio of the Total Labor Force (in %) in Hungary in 1994 to that in 2001?
Ensure brevity in your answer.  1.07. What is the ratio of the Total Labor Force (in %) of Lithuania in 1994 to that in 2001?
Give a very brief answer. 1.44. What is the ratio of the Total Labor Force (in %) of Netherlands in 1994 to that in 2001?
Your response must be concise. 0.82. What is the ratio of the Total Labor Force (in %) of Equatorial Guinea in 1995 to that in 1996?
Your response must be concise. 1. What is the ratio of the Total Labor Force (in %) of Hungary in 1995 to that in 1996?
Ensure brevity in your answer.  1.02. What is the ratio of the Total Labor Force (in %) of Lithuania in 1995 to that in 1996?
Your answer should be compact. 1. What is the ratio of the Total Labor Force (in %) in Netherlands in 1995 to that in 1996?
Offer a very short reply. 1.01. What is the ratio of the Total Labor Force (in %) in Equatorial Guinea in 1995 to that in 1997?
Offer a terse response. 1. What is the ratio of the Total Labor Force (in %) of Hungary in 1995 to that in 1997?
Ensure brevity in your answer.  1.05. What is the ratio of the Total Labor Force (in %) in Lithuania in 1995 to that in 1997?
Keep it short and to the point. 1.01. What is the ratio of the Total Labor Force (in %) in Hungary in 1995 to that in 1998?
Keep it short and to the point. 1.03. What is the ratio of the Total Labor Force (in %) in Lithuania in 1995 to that in 1998?
Provide a succinct answer. 1.04. What is the ratio of the Total Labor Force (in %) in Netherlands in 1995 to that in 1998?
Provide a succinct answer. 0.92. What is the ratio of the Total Labor Force (in %) in Equatorial Guinea in 1995 to that in 1999?
Ensure brevity in your answer.  1.01. What is the ratio of the Total Labor Force (in %) in Hungary in 1995 to that in 1999?
Your response must be concise. 1.03. What is the ratio of the Total Labor Force (in %) of Lithuania in 1995 to that in 1999?
Offer a very short reply. 1.14. What is the ratio of the Total Labor Force (in %) in Equatorial Guinea in 1995 to that in 2000?
Offer a terse response. 1.01. What is the ratio of the Total Labor Force (in %) of Hungary in 1995 to that in 2000?
Make the answer very short. 1.07. What is the ratio of the Total Labor Force (in %) of Lithuania in 1995 to that in 2000?
Offer a very short reply. 1.32. What is the ratio of the Total Labor Force (in %) in Netherlands in 1995 to that in 2000?
Offer a terse response. 0.85. What is the ratio of the Total Labor Force (in %) of Equatorial Guinea in 1995 to that in 2001?
Offer a terse response. 1.02. What is the ratio of the Total Labor Force (in %) of Hungary in 1995 to that in 2001?
Your answer should be compact. 1.13. What is the ratio of the Total Labor Force (in %) in Lithuania in 1995 to that in 2001?
Your answer should be very brief. 1.44. What is the ratio of the Total Labor Force (in %) of Netherlands in 1995 to that in 2001?
Make the answer very short. 0.83. What is the ratio of the Total Labor Force (in %) of Hungary in 1996 to that in 1997?
Provide a short and direct response. 1.03. What is the ratio of the Total Labor Force (in %) in Netherlands in 1996 to that in 1997?
Offer a terse response. 0.95. What is the ratio of the Total Labor Force (in %) in Hungary in 1996 to that in 1998?
Offer a very short reply. 1.01. What is the ratio of the Total Labor Force (in %) of Lithuania in 1996 to that in 1998?
Make the answer very short. 1.04. What is the ratio of the Total Labor Force (in %) of Netherlands in 1996 to that in 1998?
Keep it short and to the point. 0.91. What is the ratio of the Total Labor Force (in %) of Equatorial Guinea in 1996 to that in 1999?
Your answer should be compact. 1.01. What is the ratio of the Total Labor Force (in %) of Hungary in 1996 to that in 1999?
Offer a terse response. 1.01. What is the ratio of the Total Labor Force (in %) of Lithuania in 1996 to that in 1999?
Make the answer very short. 1.14. What is the ratio of the Total Labor Force (in %) in Netherlands in 1996 to that in 1999?
Your answer should be compact. 0.91. What is the ratio of the Total Labor Force (in %) of Equatorial Guinea in 1996 to that in 2000?
Make the answer very short. 1.01. What is the ratio of the Total Labor Force (in %) in Hungary in 1996 to that in 2000?
Ensure brevity in your answer.  1.04. What is the ratio of the Total Labor Force (in %) in Lithuania in 1996 to that in 2000?
Your response must be concise. 1.31. What is the ratio of the Total Labor Force (in %) in Netherlands in 1996 to that in 2000?
Provide a short and direct response. 0.84. What is the ratio of the Total Labor Force (in %) of Equatorial Guinea in 1996 to that in 2001?
Provide a short and direct response. 1.02. What is the ratio of the Total Labor Force (in %) in Hungary in 1996 to that in 2001?
Ensure brevity in your answer.  1.1. What is the ratio of the Total Labor Force (in %) of Lithuania in 1996 to that in 2001?
Offer a very short reply. 1.44. What is the ratio of the Total Labor Force (in %) of Netherlands in 1996 to that in 2001?
Give a very brief answer. 0.83. What is the ratio of the Total Labor Force (in %) of Equatorial Guinea in 1997 to that in 1998?
Provide a succinct answer. 1. What is the ratio of the Total Labor Force (in %) in Hungary in 1997 to that in 1998?
Offer a terse response. 0.98. What is the ratio of the Total Labor Force (in %) of Lithuania in 1997 to that in 1998?
Your answer should be compact. 1.04. What is the ratio of the Total Labor Force (in %) in Netherlands in 1997 to that in 1998?
Provide a succinct answer. 0.96. What is the ratio of the Total Labor Force (in %) of Hungary in 1997 to that in 1999?
Your answer should be compact. 0.98. What is the ratio of the Total Labor Force (in %) of Lithuania in 1997 to that in 1999?
Ensure brevity in your answer.  1.13. What is the ratio of the Total Labor Force (in %) in Hungary in 1997 to that in 2000?
Make the answer very short. 1.02. What is the ratio of the Total Labor Force (in %) of Lithuania in 1997 to that in 2000?
Keep it short and to the point. 1.31. What is the ratio of the Total Labor Force (in %) in Netherlands in 1997 to that in 2000?
Keep it short and to the point. 0.88. What is the ratio of the Total Labor Force (in %) in Equatorial Guinea in 1997 to that in 2001?
Offer a terse response. 1.01. What is the ratio of the Total Labor Force (in %) of Hungary in 1997 to that in 2001?
Your answer should be very brief. 1.07. What is the ratio of the Total Labor Force (in %) of Lithuania in 1997 to that in 2001?
Your response must be concise. 1.43. What is the ratio of the Total Labor Force (in %) in Netherlands in 1997 to that in 2001?
Provide a succinct answer. 0.87. What is the ratio of the Total Labor Force (in %) of Hungary in 1998 to that in 1999?
Keep it short and to the point. 1. What is the ratio of the Total Labor Force (in %) in Lithuania in 1998 to that in 1999?
Give a very brief answer. 1.09. What is the ratio of the Total Labor Force (in %) in Netherlands in 1998 to that in 1999?
Provide a succinct answer. 1. What is the ratio of the Total Labor Force (in %) of Hungary in 1998 to that in 2000?
Make the answer very short. 1.04. What is the ratio of the Total Labor Force (in %) in Lithuania in 1998 to that in 2000?
Your answer should be very brief. 1.26. What is the ratio of the Total Labor Force (in %) in Netherlands in 1998 to that in 2000?
Provide a short and direct response. 0.92. What is the ratio of the Total Labor Force (in %) in Hungary in 1998 to that in 2001?
Your response must be concise. 1.09. What is the ratio of the Total Labor Force (in %) in Lithuania in 1998 to that in 2001?
Your response must be concise. 1.38. What is the ratio of the Total Labor Force (in %) of Netherlands in 1998 to that in 2001?
Offer a terse response. 0.91. What is the ratio of the Total Labor Force (in %) of Equatorial Guinea in 1999 to that in 2000?
Your answer should be compact. 1. What is the ratio of the Total Labor Force (in %) of Hungary in 1999 to that in 2000?
Provide a short and direct response. 1.04. What is the ratio of the Total Labor Force (in %) in Lithuania in 1999 to that in 2000?
Give a very brief answer. 1.16. What is the ratio of the Total Labor Force (in %) of Netherlands in 1999 to that in 2000?
Offer a very short reply. 0.92. What is the ratio of the Total Labor Force (in %) of Hungary in 1999 to that in 2001?
Offer a very short reply. 1.09. What is the ratio of the Total Labor Force (in %) of Lithuania in 1999 to that in 2001?
Ensure brevity in your answer.  1.26. What is the ratio of the Total Labor Force (in %) in Netherlands in 1999 to that in 2001?
Your answer should be compact. 0.91. What is the ratio of the Total Labor Force (in %) in Equatorial Guinea in 2000 to that in 2001?
Make the answer very short. 1. What is the ratio of the Total Labor Force (in %) in Hungary in 2000 to that in 2001?
Offer a very short reply. 1.06. What is the ratio of the Total Labor Force (in %) in Lithuania in 2000 to that in 2001?
Provide a short and direct response. 1.09. What is the ratio of the Total Labor Force (in %) of Netherlands in 2000 to that in 2001?
Give a very brief answer. 0.99. What is the difference between the highest and the second highest Total Labor Force (in %) of Equatorial Guinea?
Offer a terse response. 0. What is the difference between the highest and the second highest Total Labor Force (in %) in Hungary?
Provide a succinct answer. 1.1. What is the difference between the highest and the second highest Total Labor Force (in %) in Netherlands?
Provide a short and direct response. 1.1. What is the difference between the highest and the lowest Total Labor Force (in %) in Equatorial Guinea?
Offer a very short reply. 1.5. What is the difference between the highest and the lowest Total Labor Force (in %) in Hungary?
Provide a succinct answer. 5.2. What is the difference between the highest and the lowest Total Labor Force (in %) in Netherlands?
Offer a terse response. 13.1. 